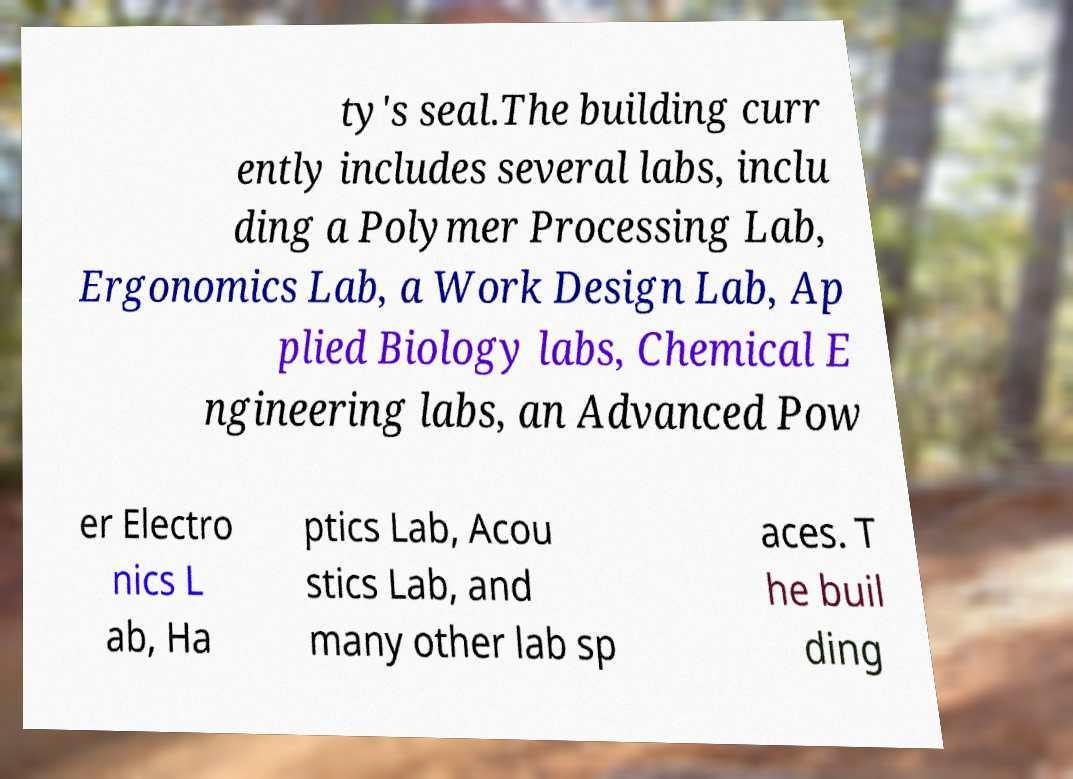Can you accurately transcribe the text from the provided image for me? ty's seal.The building curr ently includes several labs, inclu ding a Polymer Processing Lab, Ergonomics Lab, a Work Design Lab, Ap plied Biology labs, Chemical E ngineering labs, an Advanced Pow er Electro nics L ab, Ha ptics Lab, Acou stics Lab, and many other lab sp aces. T he buil ding 